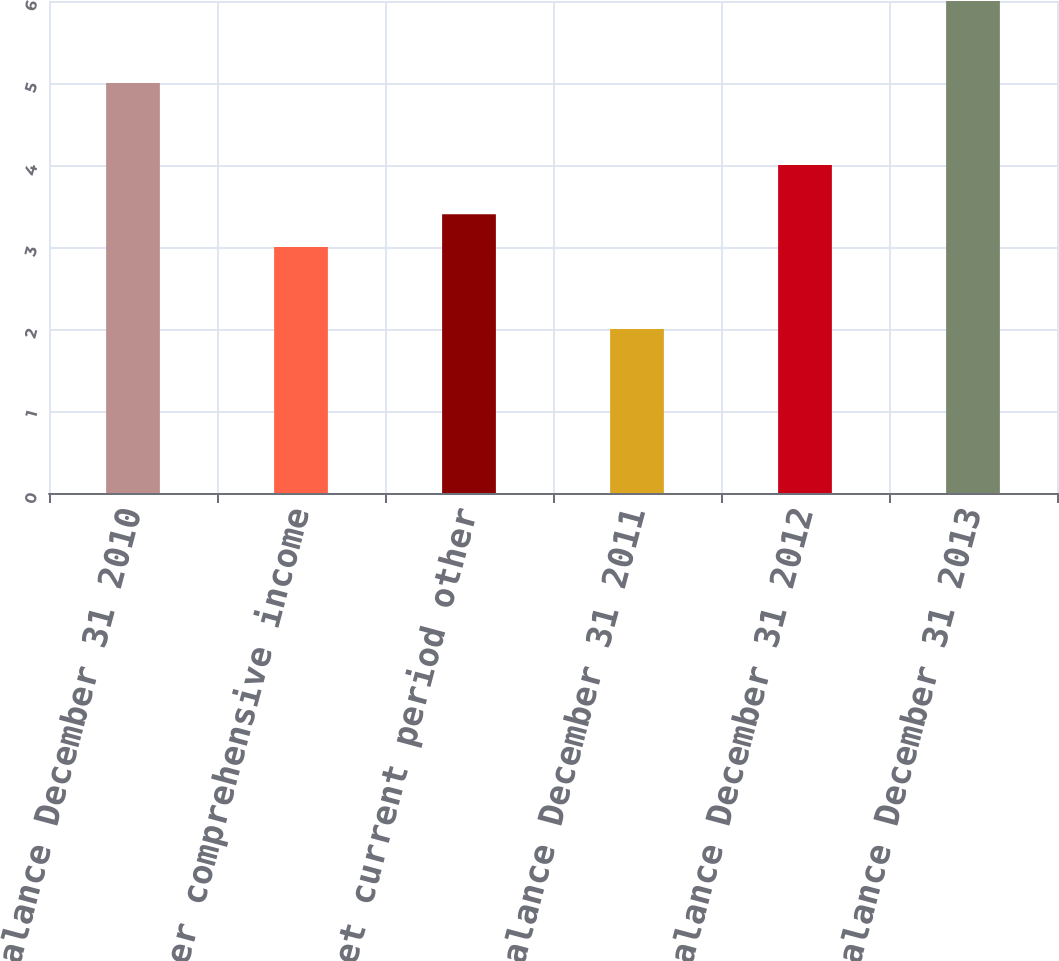Convert chart to OTSL. <chart><loc_0><loc_0><loc_500><loc_500><bar_chart><fcel>Balance December 31 2010<fcel>Other comprehensive income<fcel>Net current period other<fcel>Balance December 31 2011<fcel>Balance December 31 2012<fcel>Balance December 31 2013<nl><fcel>5<fcel>3<fcel>3.4<fcel>2<fcel>4<fcel>6<nl></chart> 